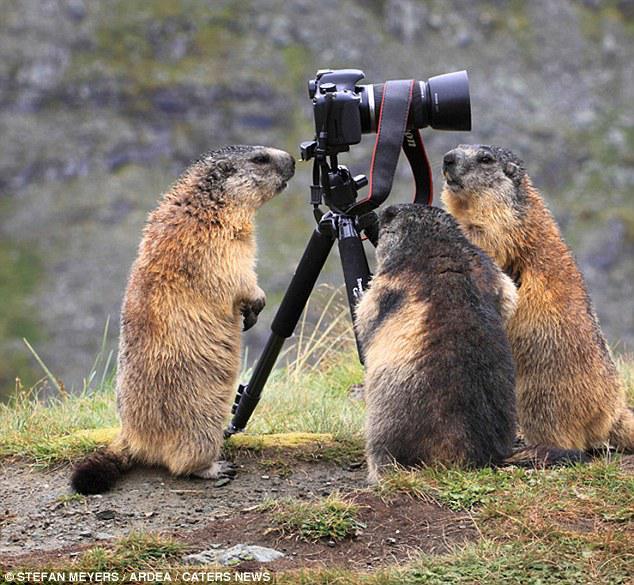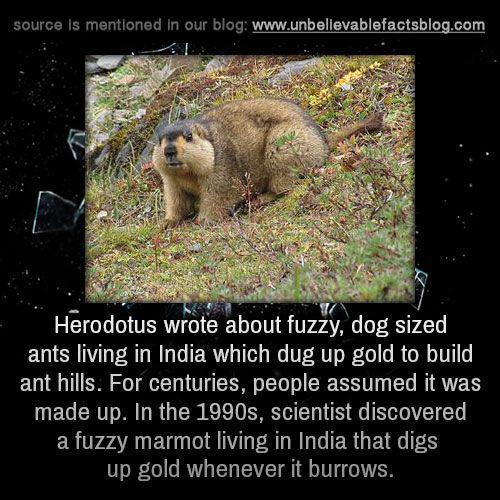The first image is the image on the left, the second image is the image on the right. Evaluate the accuracy of this statement regarding the images: "In one of the images there is an animal facing right.". Is it true? Answer yes or no. Yes. The first image is the image on the left, the second image is the image on the right. For the images displayed, is the sentence "Both beavers on the left side are standing up on their hind legs." factually correct? Answer yes or no. No. 